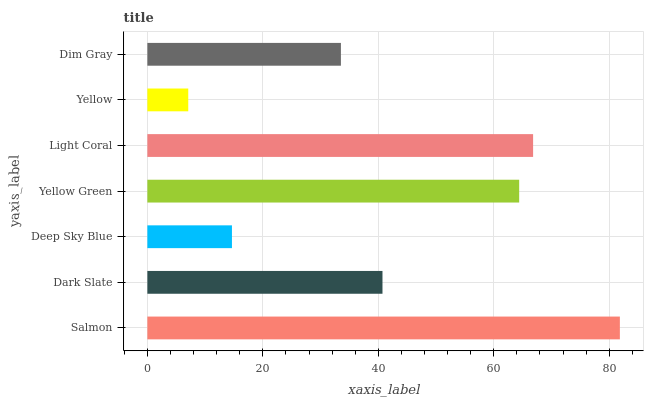Is Yellow the minimum?
Answer yes or no. Yes. Is Salmon the maximum?
Answer yes or no. Yes. Is Dark Slate the minimum?
Answer yes or no. No. Is Dark Slate the maximum?
Answer yes or no. No. Is Salmon greater than Dark Slate?
Answer yes or no. Yes. Is Dark Slate less than Salmon?
Answer yes or no. Yes. Is Dark Slate greater than Salmon?
Answer yes or no. No. Is Salmon less than Dark Slate?
Answer yes or no. No. Is Dark Slate the high median?
Answer yes or no. Yes. Is Dark Slate the low median?
Answer yes or no. Yes. Is Salmon the high median?
Answer yes or no. No. Is Yellow Green the low median?
Answer yes or no. No. 